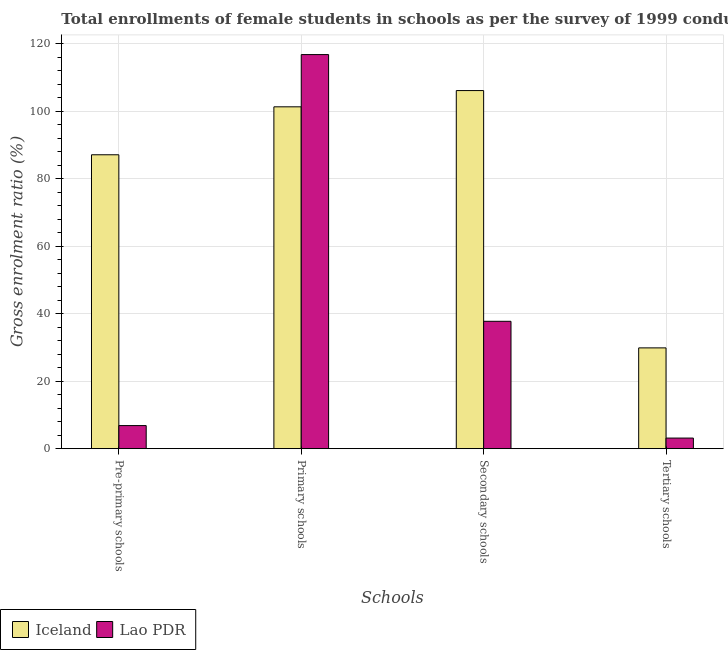How many different coloured bars are there?
Your answer should be very brief. 2. How many groups of bars are there?
Offer a terse response. 4. Are the number of bars per tick equal to the number of legend labels?
Ensure brevity in your answer.  Yes. Are the number of bars on each tick of the X-axis equal?
Make the answer very short. Yes. How many bars are there on the 4th tick from the left?
Your answer should be very brief. 2. How many bars are there on the 4th tick from the right?
Ensure brevity in your answer.  2. What is the label of the 2nd group of bars from the left?
Make the answer very short. Primary schools. What is the gross enrolment ratio(female) in pre-primary schools in Iceland?
Provide a short and direct response. 87.15. Across all countries, what is the maximum gross enrolment ratio(female) in secondary schools?
Offer a terse response. 106.18. Across all countries, what is the minimum gross enrolment ratio(female) in pre-primary schools?
Your answer should be compact. 6.85. In which country was the gross enrolment ratio(female) in secondary schools minimum?
Provide a succinct answer. Lao PDR. What is the total gross enrolment ratio(female) in pre-primary schools in the graph?
Ensure brevity in your answer.  93.99. What is the difference between the gross enrolment ratio(female) in primary schools in Iceland and that in Lao PDR?
Your answer should be very brief. -15.49. What is the difference between the gross enrolment ratio(female) in secondary schools in Lao PDR and the gross enrolment ratio(female) in pre-primary schools in Iceland?
Offer a terse response. -49.38. What is the average gross enrolment ratio(female) in pre-primary schools per country?
Offer a very short reply. 47. What is the difference between the gross enrolment ratio(female) in tertiary schools and gross enrolment ratio(female) in secondary schools in Lao PDR?
Your answer should be compact. -34.62. What is the ratio of the gross enrolment ratio(female) in secondary schools in Iceland to that in Lao PDR?
Provide a succinct answer. 2.81. Is the gross enrolment ratio(female) in tertiary schools in Lao PDR less than that in Iceland?
Provide a short and direct response. Yes. What is the difference between the highest and the second highest gross enrolment ratio(female) in pre-primary schools?
Keep it short and to the point. 80.3. What is the difference between the highest and the lowest gross enrolment ratio(female) in primary schools?
Ensure brevity in your answer.  15.49. What does the 2nd bar from the left in Primary schools represents?
Your answer should be very brief. Lao PDR. Is it the case that in every country, the sum of the gross enrolment ratio(female) in pre-primary schools and gross enrolment ratio(female) in primary schools is greater than the gross enrolment ratio(female) in secondary schools?
Make the answer very short. Yes. How many bars are there?
Make the answer very short. 8. Are the values on the major ticks of Y-axis written in scientific E-notation?
Provide a succinct answer. No. What is the title of the graph?
Ensure brevity in your answer.  Total enrollments of female students in schools as per the survey of 1999 conducted in different countries. Does "Sierra Leone" appear as one of the legend labels in the graph?
Offer a very short reply. No. What is the label or title of the X-axis?
Your answer should be very brief. Schools. What is the label or title of the Y-axis?
Provide a succinct answer. Gross enrolment ratio (%). What is the Gross enrolment ratio (%) of Iceland in Pre-primary schools?
Offer a very short reply. 87.15. What is the Gross enrolment ratio (%) of Lao PDR in Pre-primary schools?
Your answer should be very brief. 6.85. What is the Gross enrolment ratio (%) in Iceland in Primary schools?
Provide a succinct answer. 101.37. What is the Gross enrolment ratio (%) in Lao PDR in Primary schools?
Ensure brevity in your answer.  116.85. What is the Gross enrolment ratio (%) of Iceland in Secondary schools?
Provide a succinct answer. 106.18. What is the Gross enrolment ratio (%) in Lao PDR in Secondary schools?
Your answer should be very brief. 37.77. What is the Gross enrolment ratio (%) of Iceland in Tertiary schools?
Your answer should be compact. 29.89. What is the Gross enrolment ratio (%) in Lao PDR in Tertiary schools?
Your answer should be compact. 3.15. Across all Schools, what is the maximum Gross enrolment ratio (%) in Iceland?
Your answer should be very brief. 106.18. Across all Schools, what is the maximum Gross enrolment ratio (%) of Lao PDR?
Provide a short and direct response. 116.85. Across all Schools, what is the minimum Gross enrolment ratio (%) of Iceland?
Your response must be concise. 29.89. Across all Schools, what is the minimum Gross enrolment ratio (%) of Lao PDR?
Your response must be concise. 3.15. What is the total Gross enrolment ratio (%) in Iceland in the graph?
Give a very brief answer. 324.58. What is the total Gross enrolment ratio (%) of Lao PDR in the graph?
Give a very brief answer. 164.61. What is the difference between the Gross enrolment ratio (%) in Iceland in Pre-primary schools and that in Primary schools?
Ensure brevity in your answer.  -14.22. What is the difference between the Gross enrolment ratio (%) in Lao PDR in Pre-primary schools and that in Primary schools?
Your answer should be very brief. -110.01. What is the difference between the Gross enrolment ratio (%) of Iceland in Pre-primary schools and that in Secondary schools?
Provide a short and direct response. -19.03. What is the difference between the Gross enrolment ratio (%) in Lao PDR in Pre-primary schools and that in Secondary schools?
Make the answer very short. -30.92. What is the difference between the Gross enrolment ratio (%) of Iceland in Pre-primary schools and that in Tertiary schools?
Ensure brevity in your answer.  57.26. What is the difference between the Gross enrolment ratio (%) of Lao PDR in Pre-primary schools and that in Tertiary schools?
Your answer should be compact. 3.7. What is the difference between the Gross enrolment ratio (%) in Iceland in Primary schools and that in Secondary schools?
Provide a short and direct response. -4.81. What is the difference between the Gross enrolment ratio (%) in Lao PDR in Primary schools and that in Secondary schools?
Offer a very short reply. 79.09. What is the difference between the Gross enrolment ratio (%) of Iceland in Primary schools and that in Tertiary schools?
Provide a succinct answer. 71.48. What is the difference between the Gross enrolment ratio (%) in Lao PDR in Primary schools and that in Tertiary schools?
Provide a short and direct response. 113.71. What is the difference between the Gross enrolment ratio (%) in Iceland in Secondary schools and that in Tertiary schools?
Offer a terse response. 76.29. What is the difference between the Gross enrolment ratio (%) of Lao PDR in Secondary schools and that in Tertiary schools?
Make the answer very short. 34.62. What is the difference between the Gross enrolment ratio (%) of Iceland in Pre-primary schools and the Gross enrolment ratio (%) of Lao PDR in Primary schools?
Provide a succinct answer. -29.71. What is the difference between the Gross enrolment ratio (%) in Iceland in Pre-primary schools and the Gross enrolment ratio (%) in Lao PDR in Secondary schools?
Your response must be concise. 49.38. What is the difference between the Gross enrolment ratio (%) of Iceland in Pre-primary schools and the Gross enrolment ratio (%) of Lao PDR in Tertiary schools?
Your response must be concise. 84. What is the difference between the Gross enrolment ratio (%) in Iceland in Primary schools and the Gross enrolment ratio (%) in Lao PDR in Secondary schools?
Your response must be concise. 63.6. What is the difference between the Gross enrolment ratio (%) of Iceland in Primary schools and the Gross enrolment ratio (%) of Lao PDR in Tertiary schools?
Give a very brief answer. 98.22. What is the difference between the Gross enrolment ratio (%) in Iceland in Secondary schools and the Gross enrolment ratio (%) in Lao PDR in Tertiary schools?
Provide a short and direct response. 103.03. What is the average Gross enrolment ratio (%) of Iceland per Schools?
Provide a short and direct response. 81.14. What is the average Gross enrolment ratio (%) in Lao PDR per Schools?
Your answer should be compact. 41.15. What is the difference between the Gross enrolment ratio (%) in Iceland and Gross enrolment ratio (%) in Lao PDR in Pre-primary schools?
Offer a terse response. 80.3. What is the difference between the Gross enrolment ratio (%) in Iceland and Gross enrolment ratio (%) in Lao PDR in Primary schools?
Offer a very short reply. -15.49. What is the difference between the Gross enrolment ratio (%) in Iceland and Gross enrolment ratio (%) in Lao PDR in Secondary schools?
Make the answer very short. 68.41. What is the difference between the Gross enrolment ratio (%) in Iceland and Gross enrolment ratio (%) in Lao PDR in Tertiary schools?
Keep it short and to the point. 26.74. What is the ratio of the Gross enrolment ratio (%) of Iceland in Pre-primary schools to that in Primary schools?
Your answer should be compact. 0.86. What is the ratio of the Gross enrolment ratio (%) of Lao PDR in Pre-primary schools to that in Primary schools?
Your answer should be compact. 0.06. What is the ratio of the Gross enrolment ratio (%) of Iceland in Pre-primary schools to that in Secondary schools?
Keep it short and to the point. 0.82. What is the ratio of the Gross enrolment ratio (%) in Lao PDR in Pre-primary schools to that in Secondary schools?
Offer a very short reply. 0.18. What is the ratio of the Gross enrolment ratio (%) in Iceland in Pre-primary schools to that in Tertiary schools?
Provide a short and direct response. 2.92. What is the ratio of the Gross enrolment ratio (%) of Lao PDR in Pre-primary schools to that in Tertiary schools?
Give a very brief answer. 2.18. What is the ratio of the Gross enrolment ratio (%) of Iceland in Primary schools to that in Secondary schools?
Provide a short and direct response. 0.95. What is the ratio of the Gross enrolment ratio (%) in Lao PDR in Primary schools to that in Secondary schools?
Offer a very short reply. 3.09. What is the ratio of the Gross enrolment ratio (%) in Iceland in Primary schools to that in Tertiary schools?
Offer a very short reply. 3.39. What is the ratio of the Gross enrolment ratio (%) in Lao PDR in Primary schools to that in Tertiary schools?
Your response must be concise. 37.14. What is the ratio of the Gross enrolment ratio (%) of Iceland in Secondary schools to that in Tertiary schools?
Your answer should be very brief. 3.55. What is the ratio of the Gross enrolment ratio (%) in Lao PDR in Secondary schools to that in Tertiary schools?
Provide a succinct answer. 12. What is the difference between the highest and the second highest Gross enrolment ratio (%) in Iceland?
Offer a terse response. 4.81. What is the difference between the highest and the second highest Gross enrolment ratio (%) of Lao PDR?
Offer a terse response. 79.09. What is the difference between the highest and the lowest Gross enrolment ratio (%) of Iceland?
Keep it short and to the point. 76.29. What is the difference between the highest and the lowest Gross enrolment ratio (%) of Lao PDR?
Ensure brevity in your answer.  113.71. 